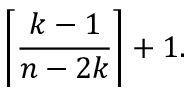<formula> <loc_0><loc_0><loc_500><loc_500>\left \lceil { \frac { k - 1 } { n - 2 k } } \right \rceil + 1 .</formula> 